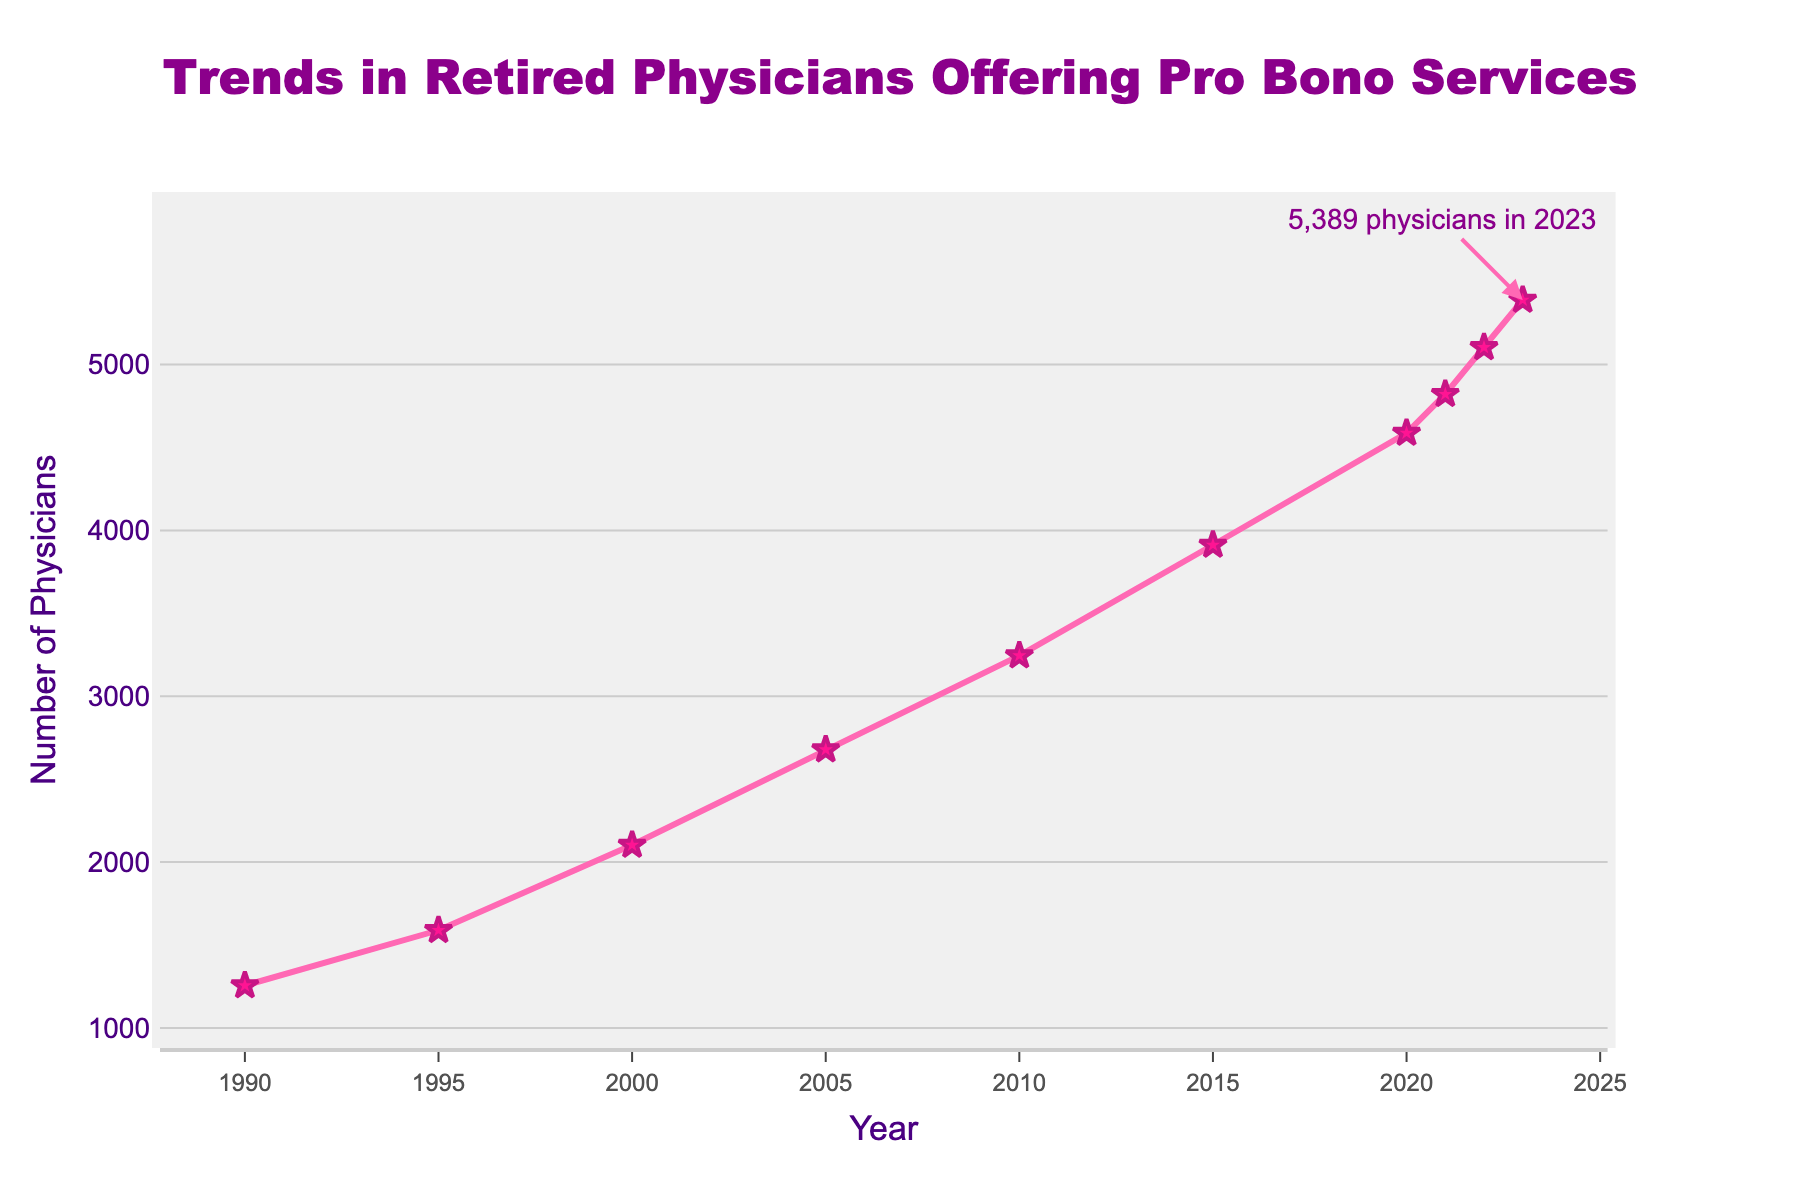what is the number of retired physicians offering pro bono services in 2005? To find this, look at the data point on the line chart corresponding to the year 2005. The y-axis value at 2005 shows the number of physicians.
Answer: 2678 how did the number of retired physicians offering pro bono services change from 1990 to 2023? To answer this, subtract the number of physicians in 1990 from the number in 2023. The values are 1256 in 1990 and 5389 in 2023. So, 5389 - 1256 = 4133
Answer: increased by 4133 between which years was the increase in the number of retired physicians offering pro bono services the most significant? Look for the years with the steepest slope on the line chart. The sharpest increase can be observed between 2015 and 2020, where the number increased from 3912 to 4587.
Answer: 2015 to 2020 what is the trend in the number of retired physicians offering pro bono services from 1990 to 2023? The overall trend can be deduced by observing the general direction of the line. The line shows a consistent upward trend from 1990 to 2023.
Answer: upward trend how many more physicians offered pro bono services in 2023 compared to 2020? To find this, subtract the number of physicians in 2020 from the number in 2023. The values are 5389 in 2023 and 4587 in 2020. So, 5389 - 4587 = 802
Answer: 802 what was the average number of retired physicians offering pro bono services per year from 1990 to 2023? To find the average, sum the number of physicians for all given years and divide by the number of years (10). The sum is 1256 + 1589 + 2103 + 2678 + 3245 + 3912 + 4587 + 4821 + 5103 + 5389 = 34683. The average is then 34683/10 = 3468.3
Answer: 3468.3 which year shows the first time the number of retired physicians offering pro bono services exceeded 3000? Identify the first data point where the y-axis value is greater than 3000. This happens in the year 2010.
Answer: 2010 by how much did the number of retired physicians offering pro bono services increase between 1995 and 2005? Subtract the number of physicians in 1995 from the number in 2005. The values are 1589 in 1995 and 2678 in 2005. So, 2678 - 1589 = 1089
Answer: 1089 